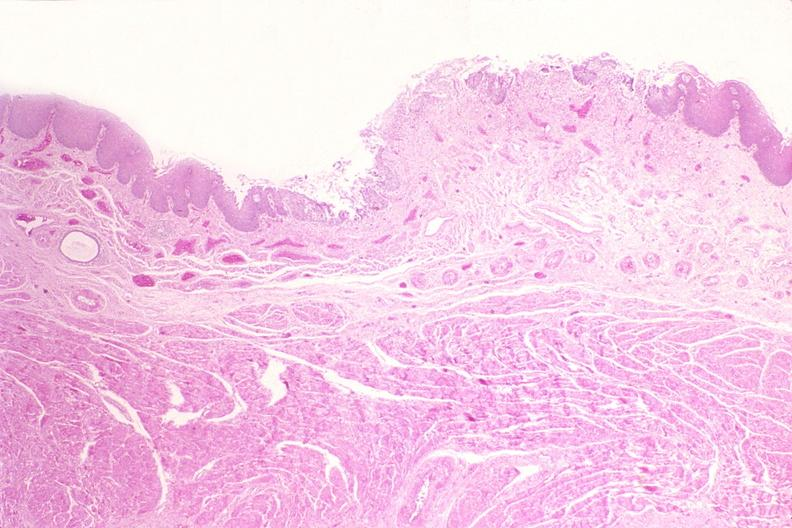s cranial artery present?
Answer the question using a single word or phrase. No 